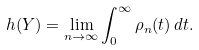Convert formula to latex. <formula><loc_0><loc_0><loc_500><loc_500>h ( Y ) = \lim _ { n \to \infty } \int _ { 0 } ^ { \infty } \rho _ { n } ( t ) \, d t .</formula> 